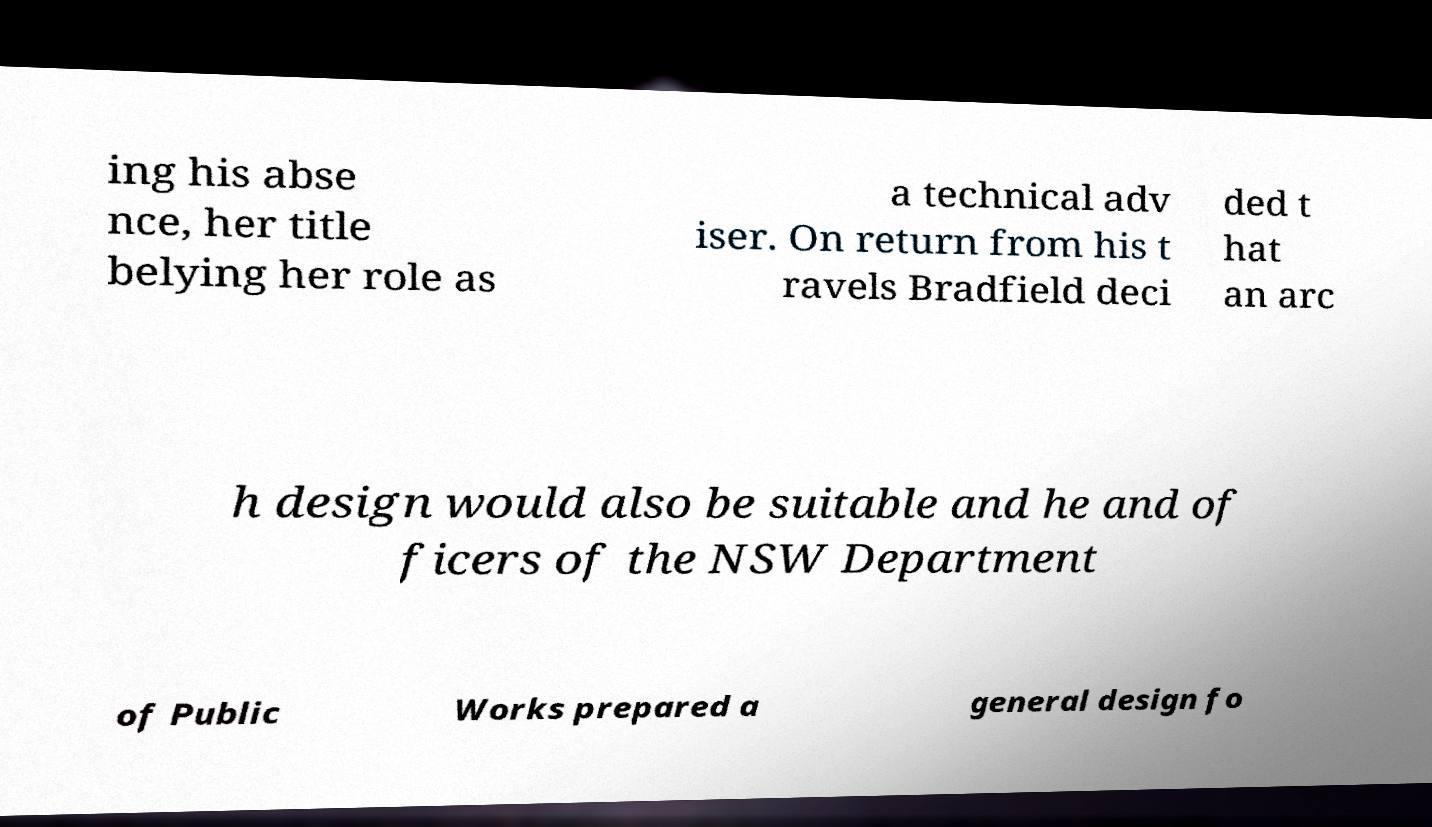I need the written content from this picture converted into text. Can you do that? ing his abse nce, her title belying her role as a technical adv iser. On return from his t ravels Bradfield deci ded t hat an arc h design would also be suitable and he and of ficers of the NSW Department of Public Works prepared a general design fo 